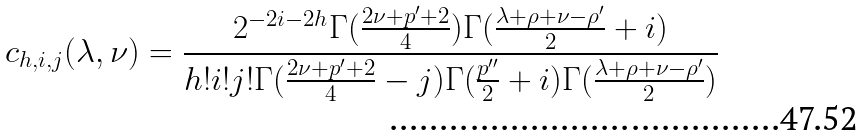<formula> <loc_0><loc_0><loc_500><loc_500>c _ { h , i , j } ( \lambda , \nu ) = \frac { 2 ^ { - 2 i - 2 h } \Gamma ( \frac { 2 \nu + p ^ { \prime } + 2 } { 4 } ) \Gamma ( \frac { \lambda + \rho + \nu - \rho ^ { \prime } } { 2 } + i ) } { h ! i ! j ! \Gamma ( \frac { 2 \nu + p ^ { \prime } + 2 } { 4 } - j ) \Gamma ( \frac { p ^ { \prime \prime } } { 2 } + i ) \Gamma ( \frac { \lambda + \rho + \nu - \rho ^ { \prime } } { 2 } ) }</formula> 